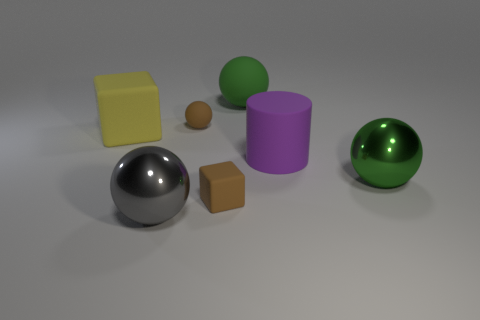Is there another large thing that has the same shape as the large purple matte thing?
Offer a very short reply. No. Does the large cylinder have the same color as the cube that is in front of the yellow cube?
Keep it short and to the point. No. The cube that is the same color as the small ball is what size?
Provide a succinct answer. Small. Are there any green rubber blocks that have the same size as the brown rubber ball?
Your answer should be very brief. No. Does the yellow object have the same material as the tiny brown thing behind the small brown matte cube?
Give a very brief answer. Yes. Are there more small rubber balls than rubber cubes?
Your answer should be compact. No. How many balls are large matte objects or green things?
Provide a short and direct response. 2. What is the color of the big cylinder?
Offer a very short reply. Purple. Does the green object that is in front of the rubber cylinder have the same size as the metal thing in front of the small rubber block?
Provide a succinct answer. Yes. Is the number of metallic objects less than the number of yellow cubes?
Your answer should be very brief. No. 